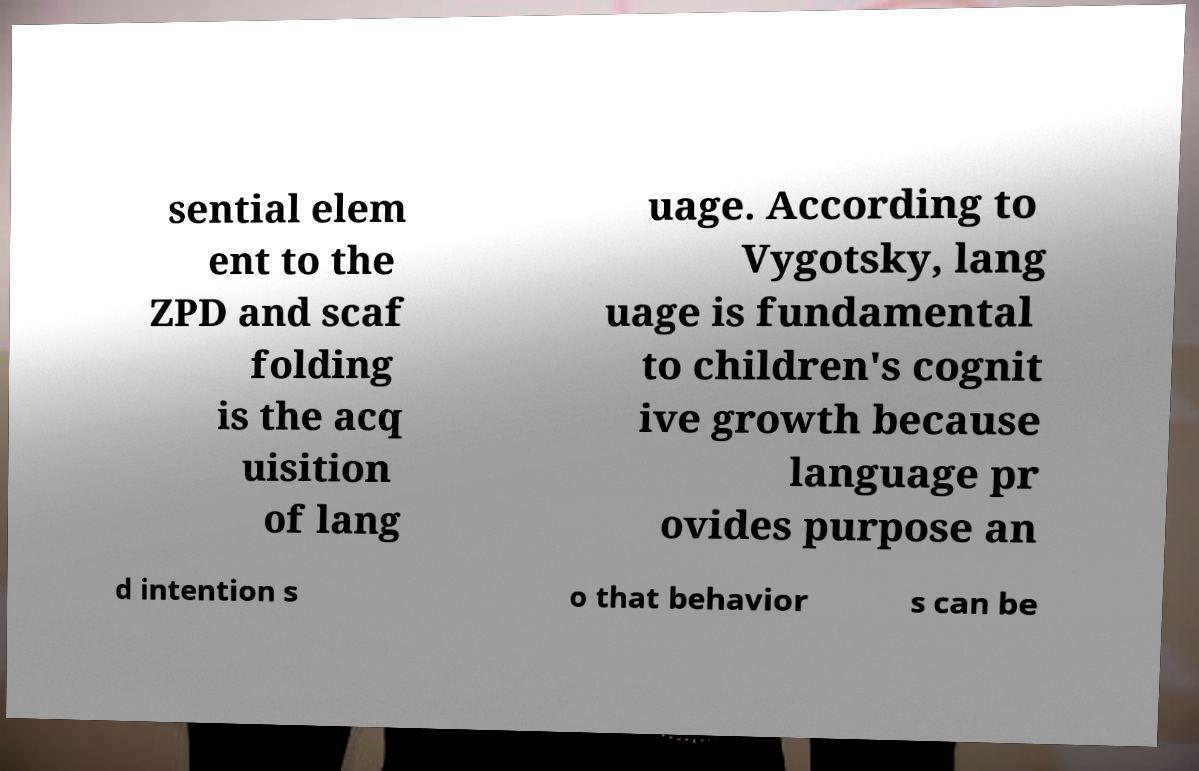There's text embedded in this image that I need extracted. Can you transcribe it verbatim? sential elem ent to the ZPD and scaf folding is the acq uisition of lang uage. According to Vygotsky, lang uage is fundamental to children's cognit ive growth because language pr ovides purpose an d intention s o that behavior s can be 